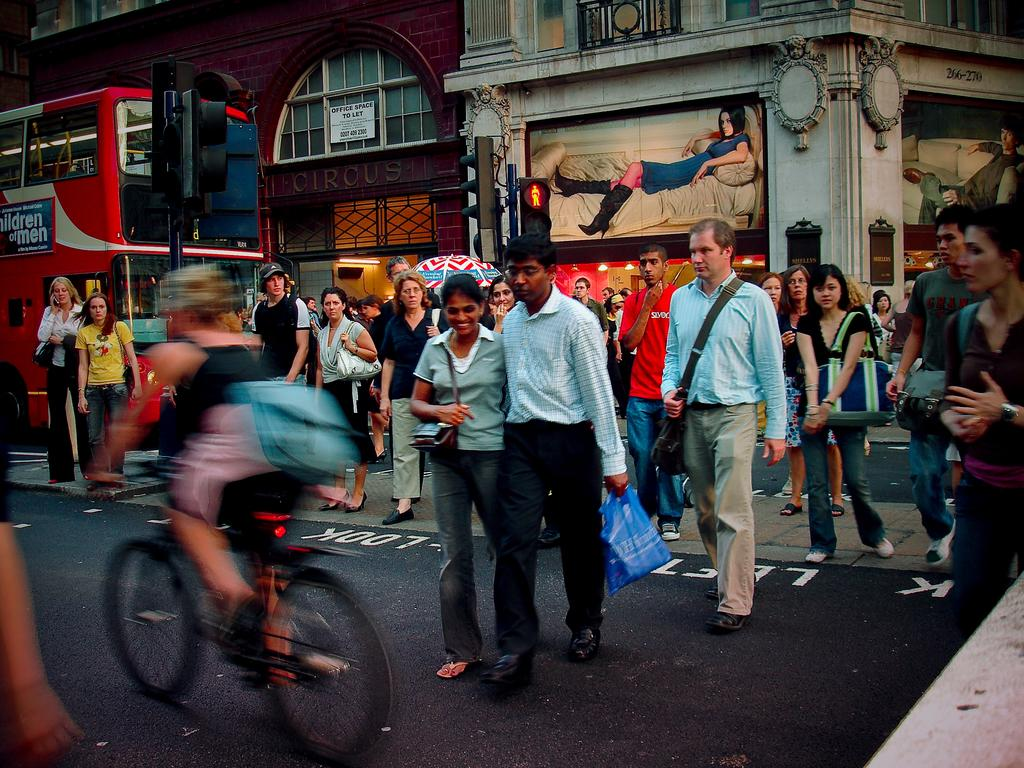What are the people in the image doing? People are crossing the road in the image. Is there any mode of transportation visible in the image? Yes, there is a person riding a bicycle and a bus in the image. What helps regulate the traffic in the image? There is a traffic signal in the image. What type of structure can be seen in the background? There is a building in the image. Can you describe the woman's position in the image? A woman is lying on a bed in the image. What type of work does the woman on the bed do in the image? There is no indication of the woman's occupation or work in the image. Can you hear the horn of the bus in the image? There is no sound information provided in the image, so it is impossible to determine if the horn of the bus can be heard. 